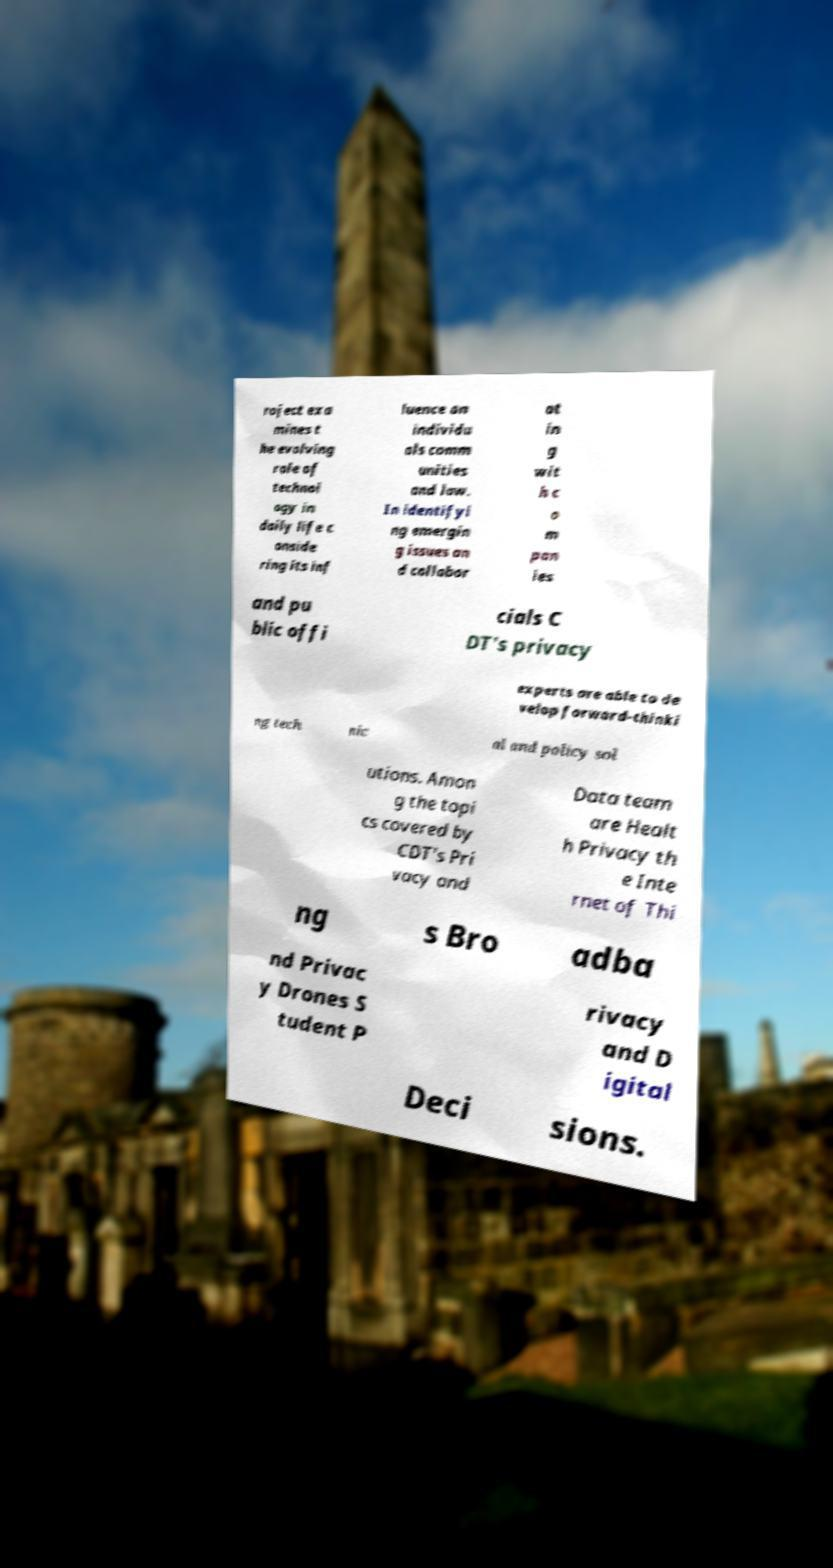Please read and relay the text visible in this image. What does it say? roject exa mines t he evolving role of technol ogy in daily life c onside ring its inf luence on individu als comm unities and law. In identifyi ng emergin g issues an d collabor at in g wit h c o m pan ies and pu blic offi cials C DT's privacy experts are able to de velop forward-thinki ng tech nic al and policy sol utions. Amon g the topi cs covered by CDT's Pri vacy and Data team are Healt h Privacy th e Inte rnet of Thi ng s Bro adba nd Privac y Drones S tudent P rivacy and D igital Deci sions. 